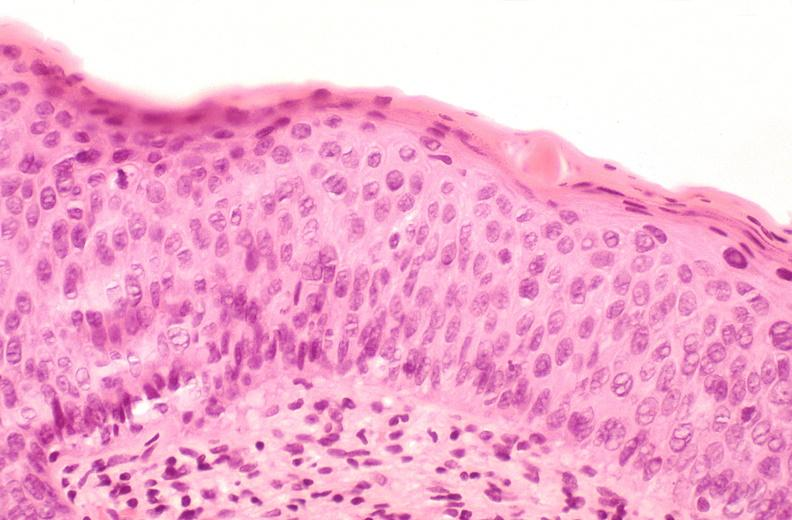does this image show cervix, moderate to severe dysplasia?
Answer the question using a single word or phrase. Yes 